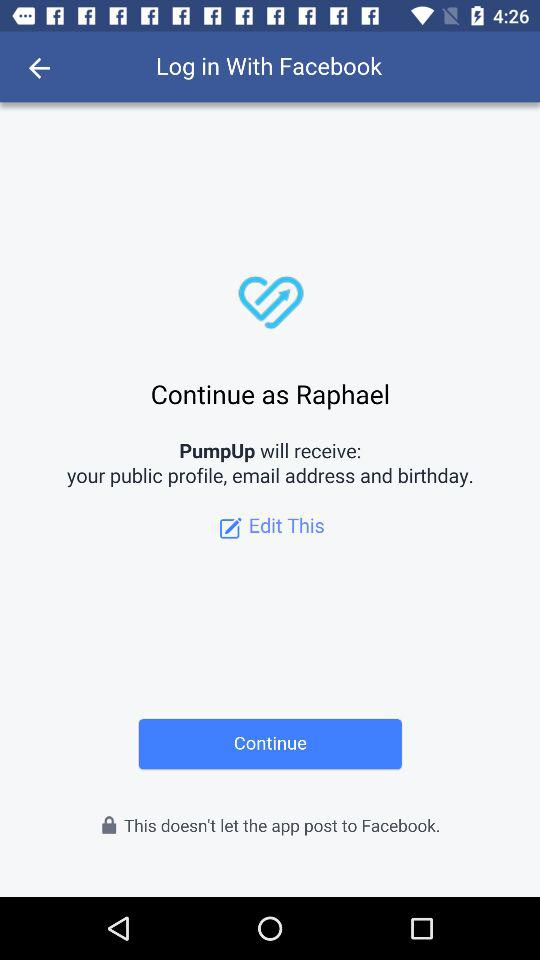Which option is selected?
When the provided information is insufficient, respond with <no answer>. <no answer> 